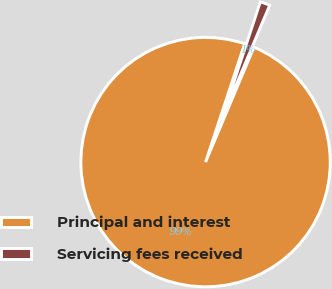Convert chart to OTSL. <chart><loc_0><loc_0><loc_500><loc_500><pie_chart><fcel>Principal and interest<fcel>Servicing fees received<nl><fcel>98.73%<fcel>1.27%<nl></chart> 